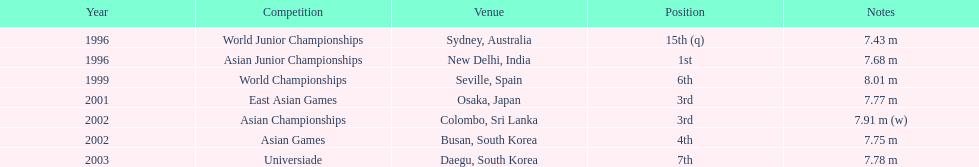What is the disparity between the frequency of achieving the third place and the frequency of achieving the first place? 1. 